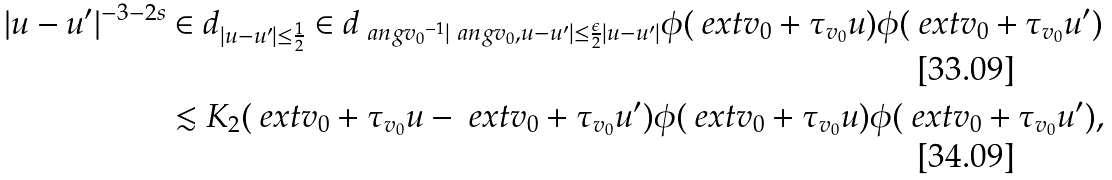<formula> <loc_0><loc_0><loc_500><loc_500>| u - u ^ { \prime } | ^ { - 3 - 2 s } & \in d _ { | u - u ^ { \prime } | \leq \frac { 1 } { 2 } } \in d _ { \ a n g { v _ { 0 } } ^ { - 1 } | \ a n g { v _ { 0 } , u - u ^ { \prime } } | \leq \frac { \epsilon } { 2 } | u - u ^ { \prime } | } \phi ( \ e x t { v _ { 0 } + \tau _ { v _ { 0 } } u } ) \phi ( \ e x t { v _ { 0 } + \tau _ { v _ { 0 } } u ^ { \prime } } ) \\ & \lesssim K _ { 2 } ( \ e x t { v _ { 0 } + \tau _ { v _ { 0 } } u } - \ e x t { v _ { 0 } + \tau _ { v _ { 0 } } u ^ { \prime } } ) \phi ( \ e x t { v _ { 0 } + \tau _ { v _ { 0 } } u } ) \phi ( \ e x t { v _ { 0 } + \tau _ { v _ { 0 } } u ^ { \prime } } ) ,</formula> 